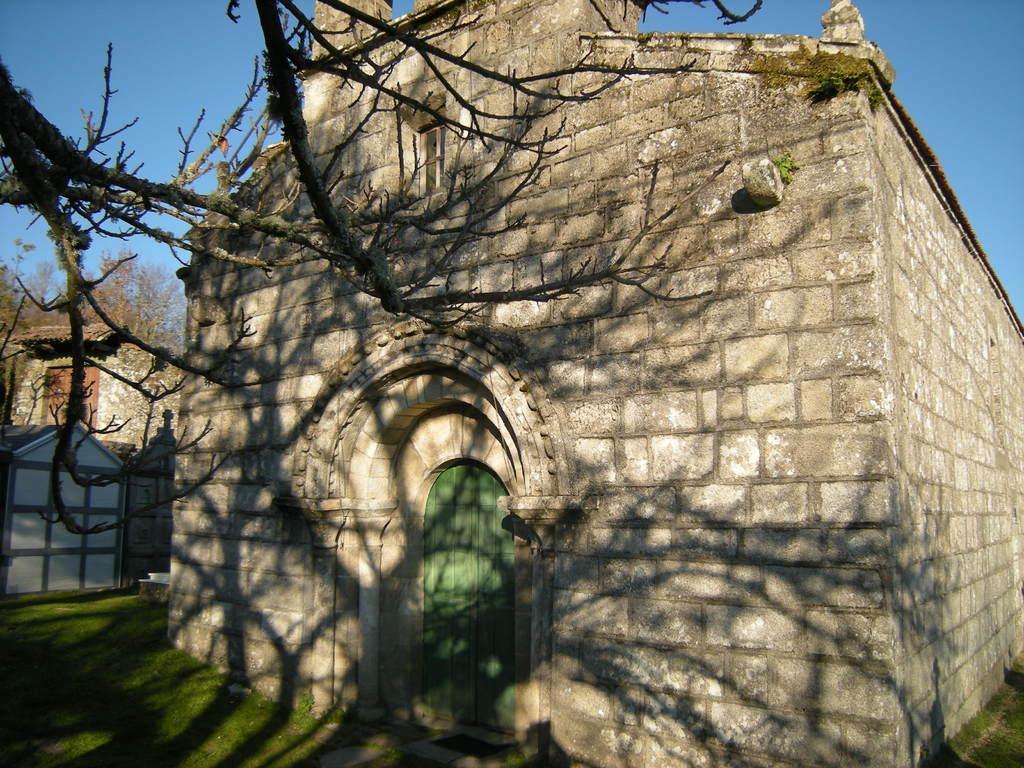In one or two sentences, can you explain what this image depicts? This picture might be taken from outside of the building and it is sunny. In this image, in the middle, we can see a building and a door which is closed. On the left side, we can see a gate, tree without leaves. At the top, we can see a sky, at the bottom, we can see a grass. 